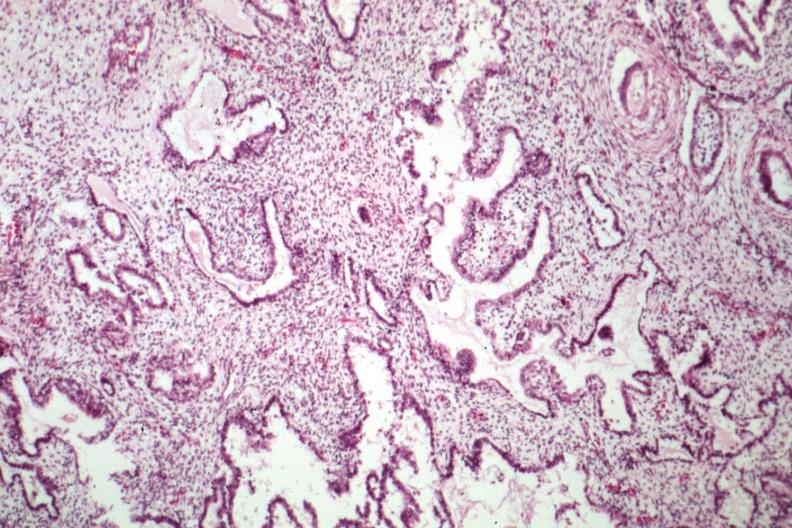what is present?
Answer the question using a single word or phrase. Sacrococcygeal teratoma 